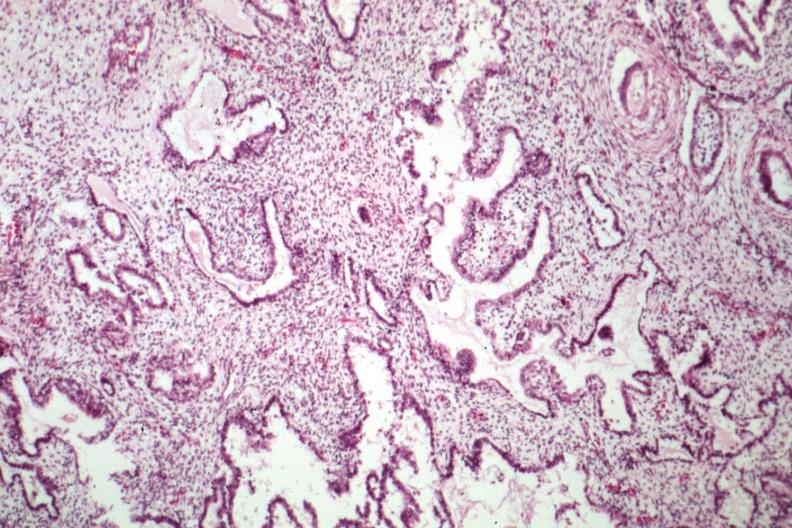what is present?
Answer the question using a single word or phrase. Sacrococcygeal teratoma 